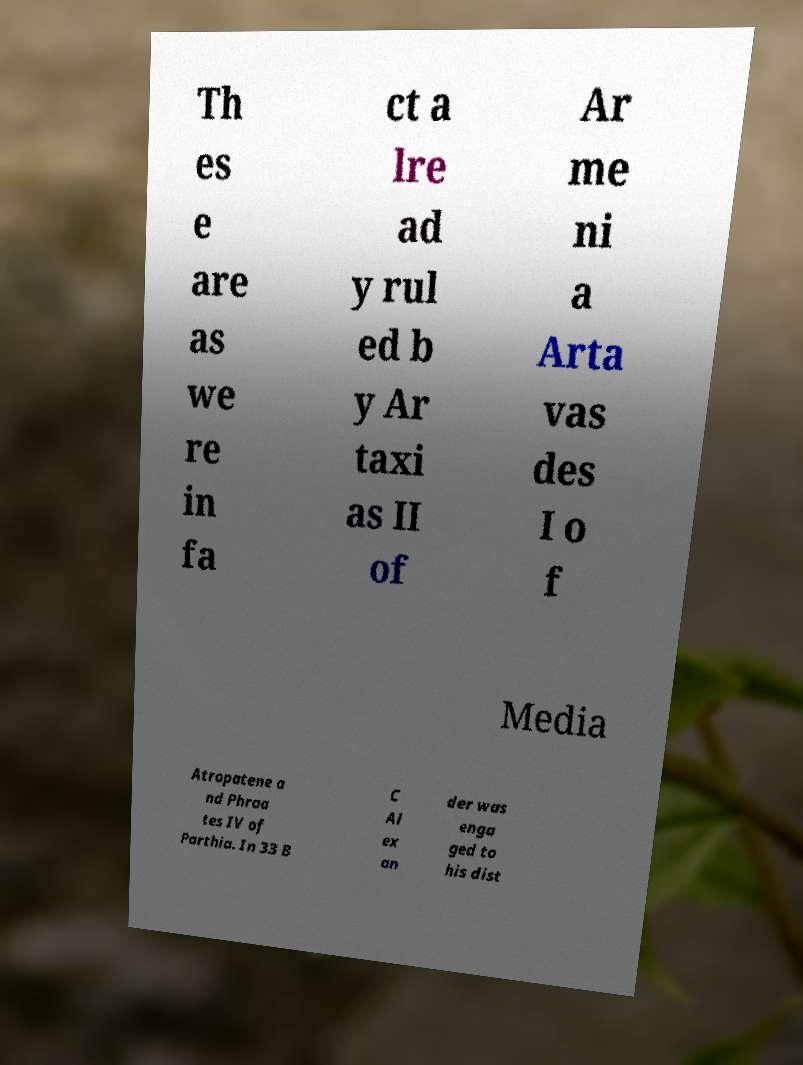Could you extract and type out the text from this image? Th es e are as we re in fa ct a lre ad y rul ed b y Ar taxi as II of Ar me ni a Arta vas des I o f Media Atropatene a nd Phraa tes IV of Parthia. In 33 B C Al ex an der was enga ged to his dist 